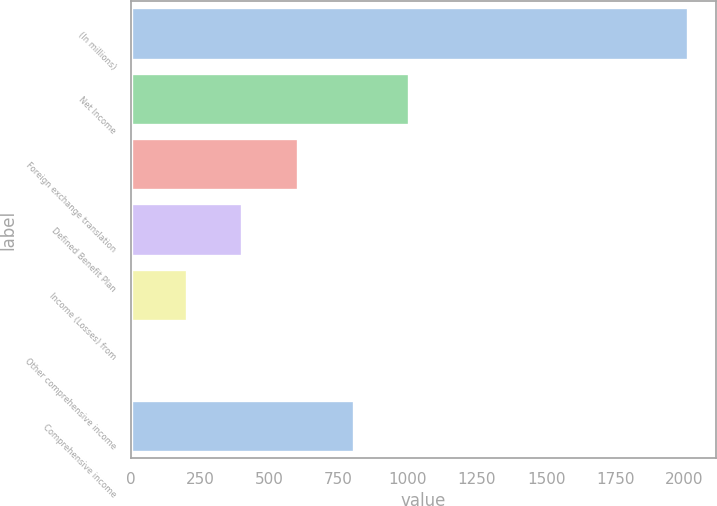Convert chart. <chart><loc_0><loc_0><loc_500><loc_500><bar_chart><fcel>(In millions)<fcel>Net Income<fcel>Foreign exchange translation<fcel>Defined Benefit Plan<fcel>Income (Losses) from<fcel>Other comprehensive income<fcel>Comprehensive income<nl><fcel>2012<fcel>1006.2<fcel>603.88<fcel>402.72<fcel>201.56<fcel>0.4<fcel>805.04<nl></chart> 